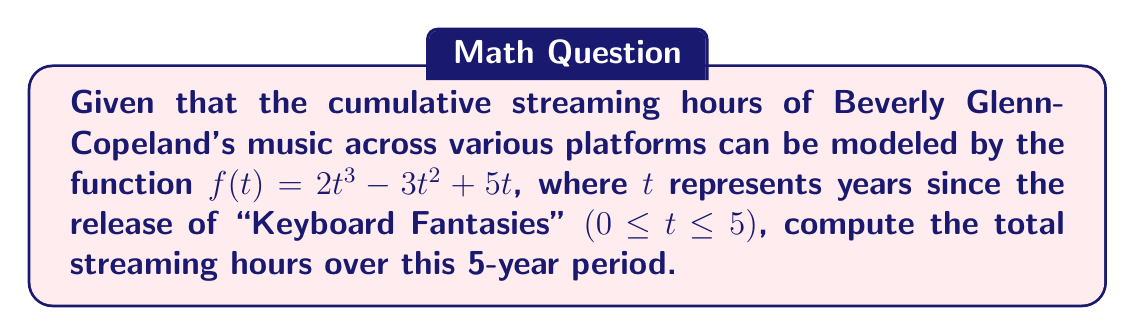Teach me how to tackle this problem. To find the total streaming hours over the 5-year period, we need to calculate the area under the curve of $f(t)$ from $t=0$ to $t=5$. This can be done using a definite integral.

1) The definite integral we need to evaluate is:
   $$\int_0^5 (2t^3 - 3t^2 + 5t) dt$$

2) Integrate each term:
   $$\left[\frac{1}{2}t^4 - t^3 + \frac{5}{2}t^2\right]_0^5$$

3) Evaluate the antiderivative at the upper and lower bounds:
   $$\left(\frac{1}{2}(5^4) - (5^3) + \frac{5}{2}(5^2)\right) - \left(\frac{1}{2}(0^4) - (0^3) + \frac{5}{2}(0^2)\right)$$

4) Simplify:
   $$\left(\frac{625}{2} - 125 + \frac{125}{2}\right) - (0 - 0 + 0)$$
   $$= \frac{625}{2} - 125 + \frac{125}{2}$$
   $$= \frac{625}{2} - \frac{250}{2} + \frac{125}{2}$$
   $$= \frac{500}{2} = 250$$

Therefore, the total streaming hours over the 5-year period is 250.
Answer: 250 hours 